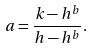<formula> <loc_0><loc_0><loc_500><loc_500>a = \frac { k - h ^ { b } } { h - h ^ { b } } .</formula> 